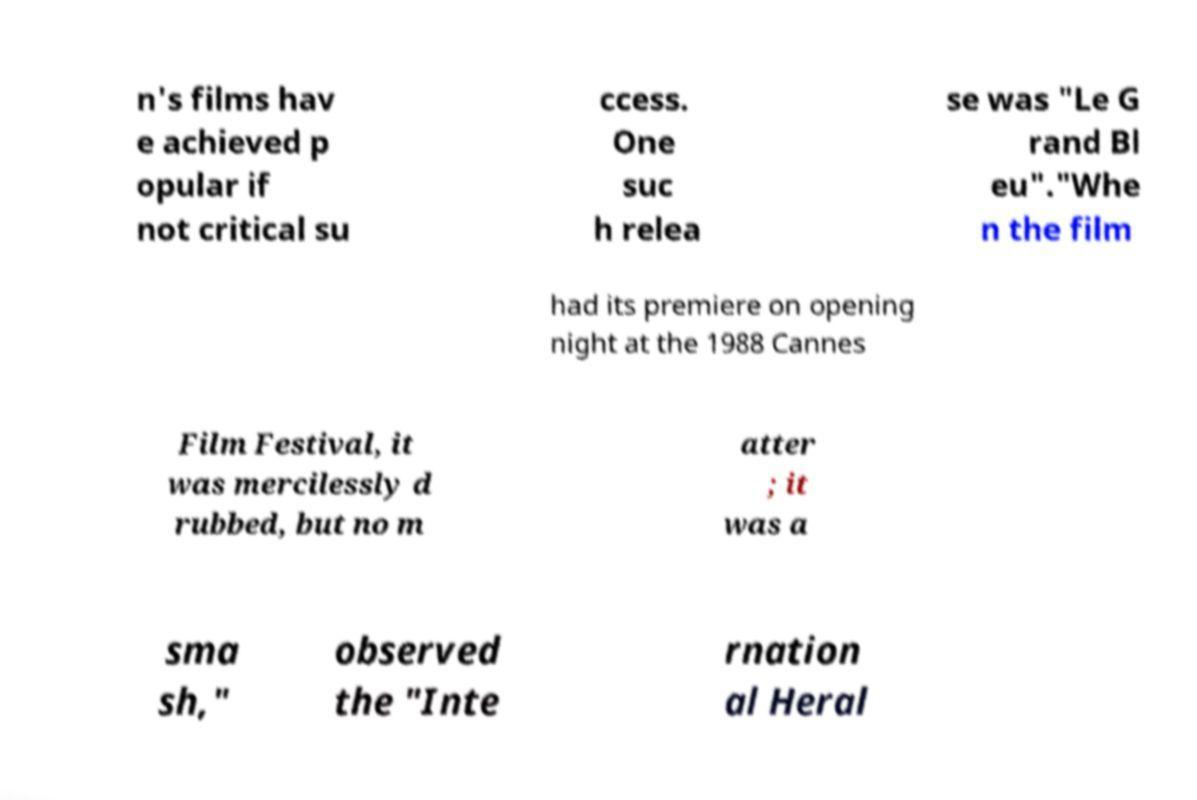Can you accurately transcribe the text from the provided image for me? n's films hav e achieved p opular if not critical su ccess. One suc h relea se was "Le G rand Bl eu"."Whe n the film had its premiere on opening night at the 1988 Cannes Film Festival, it was mercilessly d rubbed, but no m atter ; it was a sma sh," observed the "Inte rnation al Heral 